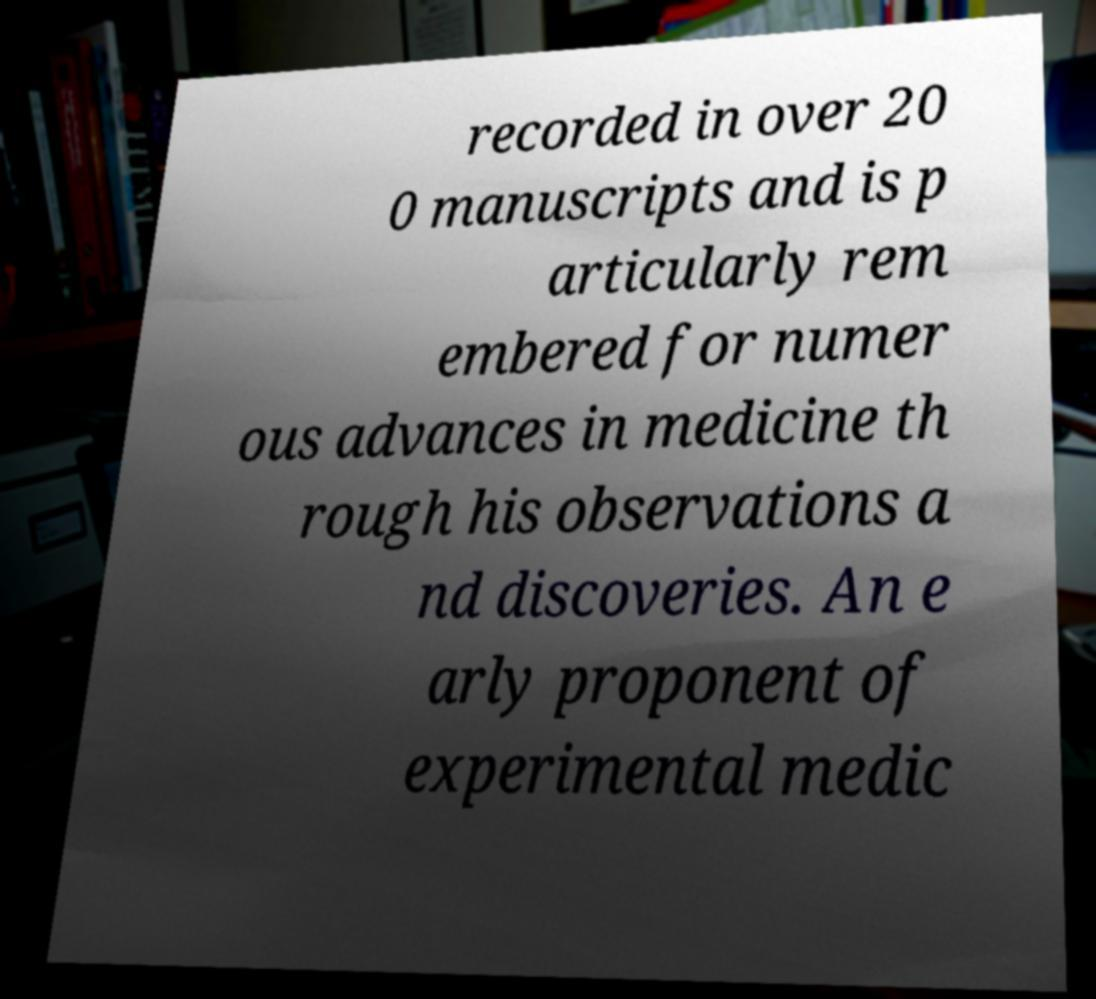Please identify and transcribe the text found in this image. recorded in over 20 0 manuscripts and is p articularly rem embered for numer ous advances in medicine th rough his observations a nd discoveries. An e arly proponent of experimental medic 